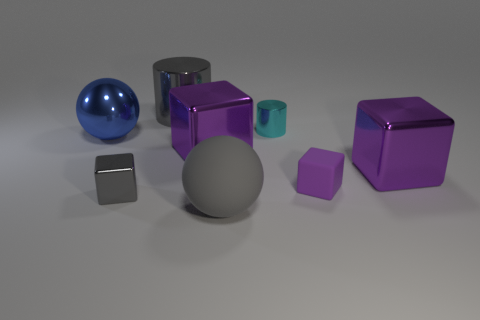Subtract all yellow balls. How many purple blocks are left? 3 Add 1 small gray metallic objects. How many objects exist? 9 Subtract all cylinders. How many objects are left? 6 Add 3 large gray objects. How many large gray objects are left? 5 Add 2 small purple shiny spheres. How many small purple shiny spheres exist? 2 Subtract 0 cyan blocks. How many objects are left? 8 Subtract all big rubber things. Subtract all cylinders. How many objects are left? 5 